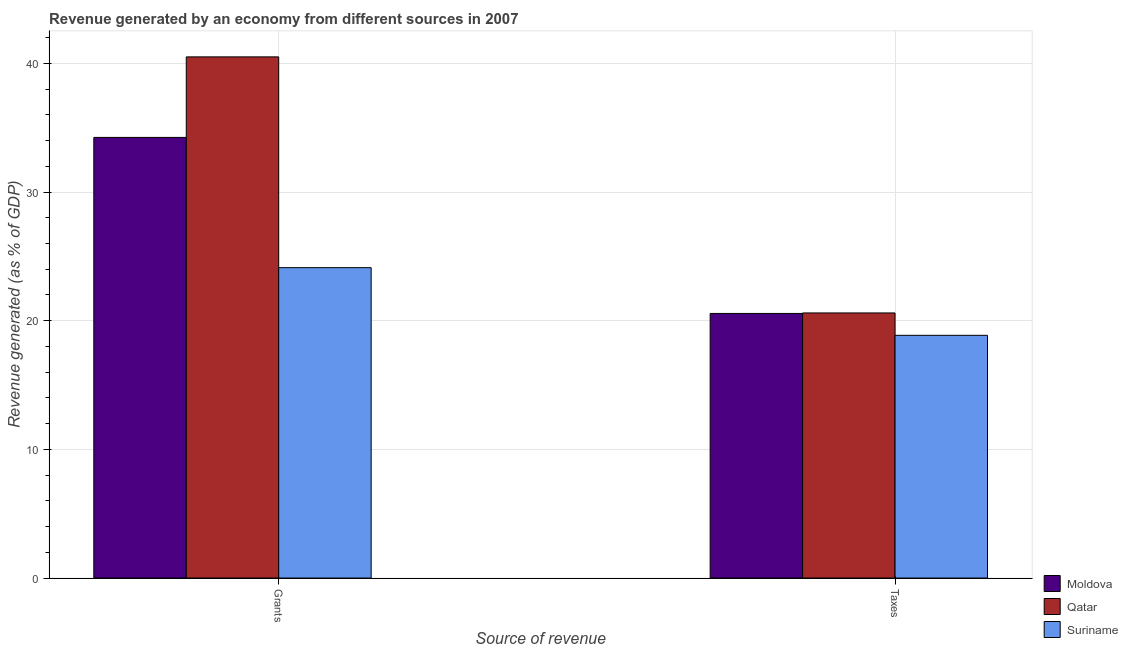How many different coloured bars are there?
Offer a very short reply. 3. How many groups of bars are there?
Your answer should be compact. 2. Are the number of bars on each tick of the X-axis equal?
Ensure brevity in your answer.  Yes. How many bars are there on the 2nd tick from the left?
Keep it short and to the point. 3. What is the label of the 2nd group of bars from the left?
Your answer should be compact. Taxes. What is the revenue generated by grants in Suriname?
Your answer should be very brief. 24.12. Across all countries, what is the maximum revenue generated by grants?
Provide a short and direct response. 40.51. Across all countries, what is the minimum revenue generated by taxes?
Give a very brief answer. 18.87. In which country was the revenue generated by taxes maximum?
Provide a short and direct response. Qatar. In which country was the revenue generated by grants minimum?
Keep it short and to the point. Suriname. What is the total revenue generated by taxes in the graph?
Your response must be concise. 60.04. What is the difference between the revenue generated by taxes in Suriname and that in Qatar?
Keep it short and to the point. -1.74. What is the difference between the revenue generated by grants in Suriname and the revenue generated by taxes in Qatar?
Make the answer very short. 3.52. What is the average revenue generated by taxes per country?
Your answer should be compact. 20.01. What is the difference between the revenue generated by taxes and revenue generated by grants in Suriname?
Your response must be concise. -5.26. What is the ratio of the revenue generated by grants in Moldova to that in Suriname?
Make the answer very short. 1.42. What does the 2nd bar from the left in Taxes represents?
Provide a succinct answer. Qatar. What does the 2nd bar from the right in Grants represents?
Provide a succinct answer. Qatar. How many bars are there?
Give a very brief answer. 6. How many countries are there in the graph?
Ensure brevity in your answer.  3. What is the difference between two consecutive major ticks on the Y-axis?
Provide a succinct answer. 10. Does the graph contain any zero values?
Provide a short and direct response. No. Does the graph contain grids?
Your answer should be compact. Yes. How many legend labels are there?
Your response must be concise. 3. How are the legend labels stacked?
Provide a short and direct response. Vertical. What is the title of the graph?
Provide a short and direct response. Revenue generated by an economy from different sources in 2007. What is the label or title of the X-axis?
Your response must be concise. Source of revenue. What is the label or title of the Y-axis?
Provide a short and direct response. Revenue generated (as % of GDP). What is the Revenue generated (as % of GDP) in Moldova in Grants?
Ensure brevity in your answer.  34.25. What is the Revenue generated (as % of GDP) in Qatar in Grants?
Give a very brief answer. 40.51. What is the Revenue generated (as % of GDP) in Suriname in Grants?
Your answer should be very brief. 24.12. What is the Revenue generated (as % of GDP) of Moldova in Taxes?
Ensure brevity in your answer.  20.57. What is the Revenue generated (as % of GDP) of Qatar in Taxes?
Ensure brevity in your answer.  20.61. What is the Revenue generated (as % of GDP) of Suriname in Taxes?
Offer a terse response. 18.87. Across all Source of revenue, what is the maximum Revenue generated (as % of GDP) in Moldova?
Your response must be concise. 34.25. Across all Source of revenue, what is the maximum Revenue generated (as % of GDP) of Qatar?
Your response must be concise. 40.51. Across all Source of revenue, what is the maximum Revenue generated (as % of GDP) in Suriname?
Offer a terse response. 24.12. Across all Source of revenue, what is the minimum Revenue generated (as % of GDP) in Moldova?
Make the answer very short. 20.57. Across all Source of revenue, what is the minimum Revenue generated (as % of GDP) of Qatar?
Make the answer very short. 20.61. Across all Source of revenue, what is the minimum Revenue generated (as % of GDP) in Suriname?
Keep it short and to the point. 18.87. What is the total Revenue generated (as % of GDP) in Moldova in the graph?
Offer a very short reply. 54.81. What is the total Revenue generated (as % of GDP) in Qatar in the graph?
Provide a succinct answer. 61.11. What is the total Revenue generated (as % of GDP) of Suriname in the graph?
Offer a very short reply. 42.99. What is the difference between the Revenue generated (as % of GDP) of Moldova in Grants and that in Taxes?
Offer a terse response. 13.68. What is the difference between the Revenue generated (as % of GDP) in Qatar in Grants and that in Taxes?
Your response must be concise. 19.9. What is the difference between the Revenue generated (as % of GDP) in Suriname in Grants and that in Taxes?
Keep it short and to the point. 5.26. What is the difference between the Revenue generated (as % of GDP) in Moldova in Grants and the Revenue generated (as % of GDP) in Qatar in Taxes?
Ensure brevity in your answer.  13.64. What is the difference between the Revenue generated (as % of GDP) in Moldova in Grants and the Revenue generated (as % of GDP) in Suriname in Taxes?
Ensure brevity in your answer.  15.38. What is the difference between the Revenue generated (as % of GDP) in Qatar in Grants and the Revenue generated (as % of GDP) in Suriname in Taxes?
Ensure brevity in your answer.  21.64. What is the average Revenue generated (as % of GDP) in Moldova per Source of revenue?
Provide a succinct answer. 27.41. What is the average Revenue generated (as % of GDP) in Qatar per Source of revenue?
Make the answer very short. 30.56. What is the average Revenue generated (as % of GDP) in Suriname per Source of revenue?
Your answer should be very brief. 21.5. What is the difference between the Revenue generated (as % of GDP) of Moldova and Revenue generated (as % of GDP) of Qatar in Grants?
Your answer should be very brief. -6.26. What is the difference between the Revenue generated (as % of GDP) in Moldova and Revenue generated (as % of GDP) in Suriname in Grants?
Keep it short and to the point. 10.12. What is the difference between the Revenue generated (as % of GDP) of Qatar and Revenue generated (as % of GDP) of Suriname in Grants?
Provide a short and direct response. 16.38. What is the difference between the Revenue generated (as % of GDP) of Moldova and Revenue generated (as % of GDP) of Qatar in Taxes?
Provide a short and direct response. -0.04. What is the difference between the Revenue generated (as % of GDP) in Moldova and Revenue generated (as % of GDP) in Suriname in Taxes?
Make the answer very short. 1.7. What is the difference between the Revenue generated (as % of GDP) of Qatar and Revenue generated (as % of GDP) of Suriname in Taxes?
Provide a succinct answer. 1.74. What is the ratio of the Revenue generated (as % of GDP) of Moldova in Grants to that in Taxes?
Provide a succinct answer. 1.67. What is the ratio of the Revenue generated (as % of GDP) in Qatar in Grants to that in Taxes?
Ensure brevity in your answer.  1.97. What is the ratio of the Revenue generated (as % of GDP) of Suriname in Grants to that in Taxes?
Offer a very short reply. 1.28. What is the difference between the highest and the second highest Revenue generated (as % of GDP) of Moldova?
Your response must be concise. 13.68. What is the difference between the highest and the second highest Revenue generated (as % of GDP) of Qatar?
Give a very brief answer. 19.9. What is the difference between the highest and the second highest Revenue generated (as % of GDP) in Suriname?
Provide a short and direct response. 5.26. What is the difference between the highest and the lowest Revenue generated (as % of GDP) of Moldova?
Offer a terse response. 13.68. What is the difference between the highest and the lowest Revenue generated (as % of GDP) in Qatar?
Offer a terse response. 19.9. What is the difference between the highest and the lowest Revenue generated (as % of GDP) of Suriname?
Offer a very short reply. 5.26. 